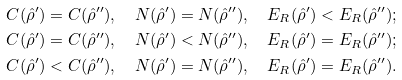Convert formula to latex. <formula><loc_0><loc_0><loc_500><loc_500>& C ( \hat { \rho } ^ { \prime } ) = C ( \hat { \rho } ^ { \prime \prime } ) , \quad N ( \hat { \rho } ^ { \prime } ) = N ( \hat { \rho } ^ { \prime \prime } ) , \quad E _ { R } ( \hat { \rho } ^ { \prime } ) < E _ { R } ( \hat { \rho } ^ { \prime \prime } ) ; \\ & C ( \hat { \rho } ^ { \prime } ) = C ( \hat { \rho } ^ { \prime \prime } ) , \quad N ( \hat { \rho } ^ { \prime } ) < N ( \hat { \rho } ^ { \prime \prime } ) , \quad E _ { R } ( \hat { \rho } ^ { \prime } ) = E _ { R } ( \hat { \rho } ^ { \prime \prime } ) ; \\ & C ( \hat { \rho } ^ { \prime } ) < C ( \hat { \rho } ^ { \prime \prime } ) , \quad N ( \hat { \rho } ^ { \prime } ) = N ( \hat { \rho } ^ { \prime \prime } ) , \quad E _ { R } ( \hat { \rho } ^ { \prime } ) = E _ { R } ( \hat { \rho } ^ { \prime \prime } ) .</formula> 